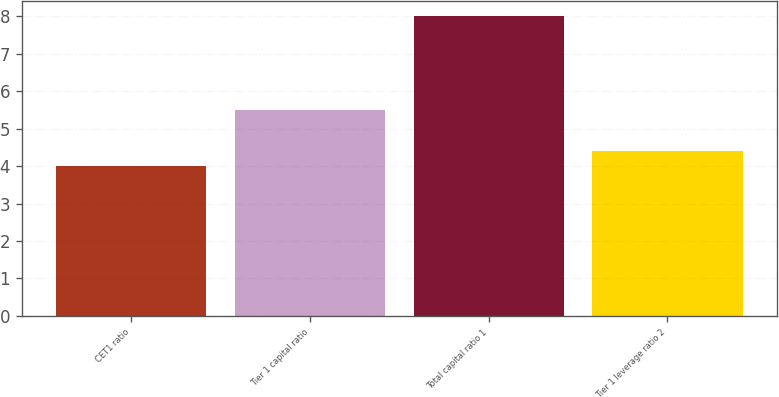Convert chart. <chart><loc_0><loc_0><loc_500><loc_500><bar_chart><fcel>CET1 ratio<fcel>Tier 1 capital ratio<fcel>Total capital ratio 1<fcel>Tier 1 leverage ratio 2<nl><fcel>4<fcel>5.5<fcel>8<fcel>4.4<nl></chart> 